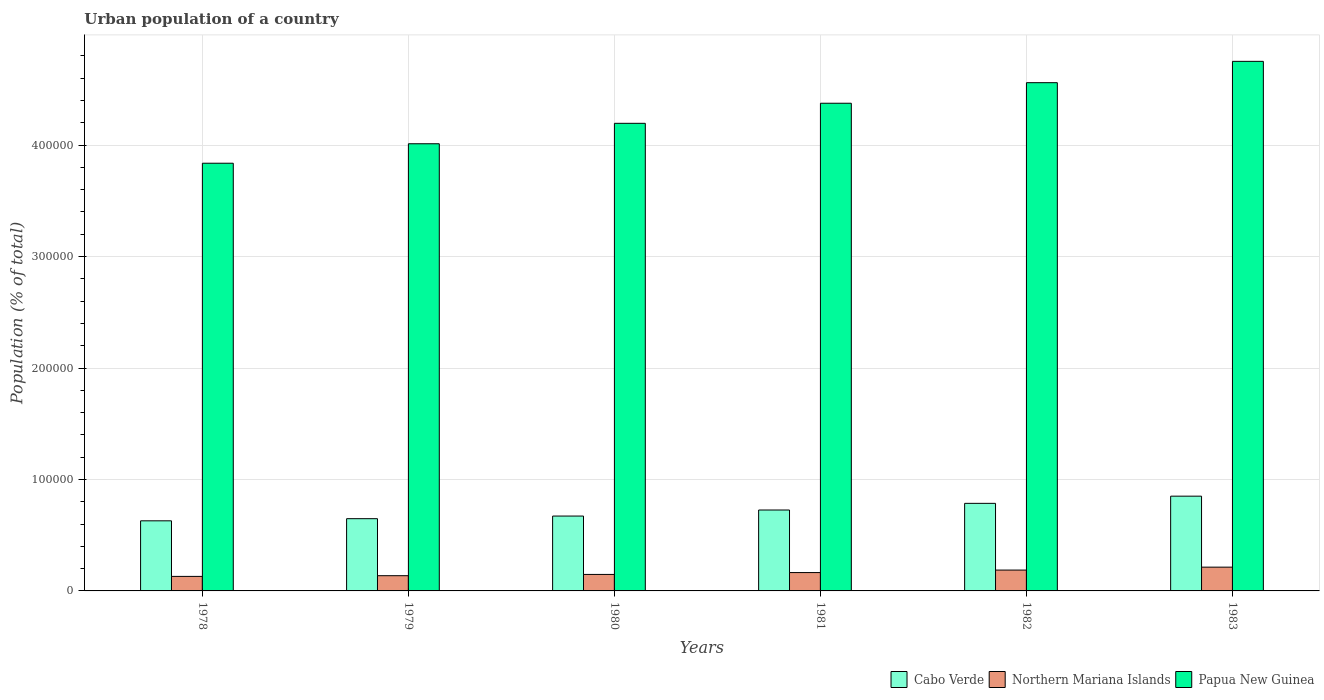How many groups of bars are there?
Ensure brevity in your answer.  6. Are the number of bars per tick equal to the number of legend labels?
Offer a very short reply. Yes. Are the number of bars on each tick of the X-axis equal?
Keep it short and to the point. Yes. How many bars are there on the 1st tick from the left?
Offer a very short reply. 3. How many bars are there on the 3rd tick from the right?
Provide a short and direct response. 3. What is the label of the 1st group of bars from the left?
Ensure brevity in your answer.  1978. What is the urban population in Northern Mariana Islands in 1981?
Ensure brevity in your answer.  1.65e+04. Across all years, what is the maximum urban population in Cabo Verde?
Make the answer very short. 8.50e+04. Across all years, what is the minimum urban population in Northern Mariana Islands?
Keep it short and to the point. 1.30e+04. In which year was the urban population in Cabo Verde minimum?
Make the answer very short. 1978. What is the total urban population in Papua New Guinea in the graph?
Your answer should be compact. 2.57e+06. What is the difference between the urban population in Cabo Verde in 1979 and that in 1982?
Give a very brief answer. -1.37e+04. What is the difference between the urban population in Cabo Verde in 1978 and the urban population in Papua New Guinea in 1980?
Your response must be concise. -3.57e+05. What is the average urban population in Northern Mariana Islands per year?
Offer a very short reply. 1.63e+04. In the year 1979, what is the difference between the urban population in Papua New Guinea and urban population in Cabo Verde?
Ensure brevity in your answer.  3.36e+05. In how many years, is the urban population in Cabo Verde greater than 240000 %?
Your response must be concise. 0. What is the ratio of the urban population in Cabo Verde in 1980 to that in 1982?
Your answer should be compact. 0.85. Is the urban population in Papua New Guinea in 1982 less than that in 1983?
Your answer should be compact. Yes. Is the difference between the urban population in Papua New Guinea in 1979 and 1982 greater than the difference between the urban population in Cabo Verde in 1979 and 1982?
Keep it short and to the point. No. What is the difference between the highest and the second highest urban population in Cabo Verde?
Offer a terse response. 6449. What is the difference between the highest and the lowest urban population in Northern Mariana Islands?
Give a very brief answer. 8305. Is the sum of the urban population in Cabo Verde in 1978 and 1981 greater than the maximum urban population in Papua New Guinea across all years?
Your answer should be very brief. No. What does the 2nd bar from the left in 1980 represents?
Offer a very short reply. Northern Mariana Islands. What does the 1st bar from the right in 1980 represents?
Your response must be concise. Papua New Guinea. Is it the case that in every year, the sum of the urban population in Papua New Guinea and urban population in Northern Mariana Islands is greater than the urban population in Cabo Verde?
Offer a very short reply. Yes. How many years are there in the graph?
Make the answer very short. 6. What is the difference between two consecutive major ticks on the Y-axis?
Give a very brief answer. 1.00e+05. Where does the legend appear in the graph?
Make the answer very short. Bottom right. What is the title of the graph?
Keep it short and to the point. Urban population of a country. Does "Belize" appear as one of the legend labels in the graph?
Give a very brief answer. No. What is the label or title of the Y-axis?
Offer a terse response. Population (% of total). What is the Population (% of total) in Cabo Verde in 1978?
Offer a terse response. 6.29e+04. What is the Population (% of total) of Northern Mariana Islands in 1978?
Your response must be concise. 1.30e+04. What is the Population (% of total) in Papua New Guinea in 1978?
Give a very brief answer. 3.84e+05. What is the Population (% of total) in Cabo Verde in 1979?
Provide a succinct answer. 6.48e+04. What is the Population (% of total) in Northern Mariana Islands in 1979?
Provide a short and direct response. 1.37e+04. What is the Population (% of total) of Papua New Guinea in 1979?
Keep it short and to the point. 4.01e+05. What is the Population (% of total) of Cabo Verde in 1980?
Provide a short and direct response. 6.72e+04. What is the Population (% of total) in Northern Mariana Islands in 1980?
Provide a short and direct response. 1.48e+04. What is the Population (% of total) of Papua New Guinea in 1980?
Make the answer very short. 4.20e+05. What is the Population (% of total) in Cabo Verde in 1981?
Your answer should be compact. 7.26e+04. What is the Population (% of total) of Northern Mariana Islands in 1981?
Your answer should be compact. 1.65e+04. What is the Population (% of total) of Papua New Guinea in 1981?
Keep it short and to the point. 4.38e+05. What is the Population (% of total) of Cabo Verde in 1982?
Ensure brevity in your answer.  7.86e+04. What is the Population (% of total) in Northern Mariana Islands in 1982?
Make the answer very short. 1.87e+04. What is the Population (% of total) in Papua New Guinea in 1982?
Offer a terse response. 4.56e+05. What is the Population (% of total) in Cabo Verde in 1983?
Your answer should be compact. 8.50e+04. What is the Population (% of total) of Northern Mariana Islands in 1983?
Offer a terse response. 2.13e+04. What is the Population (% of total) of Papua New Guinea in 1983?
Offer a terse response. 4.75e+05. Across all years, what is the maximum Population (% of total) of Cabo Verde?
Ensure brevity in your answer.  8.50e+04. Across all years, what is the maximum Population (% of total) of Northern Mariana Islands?
Offer a terse response. 2.13e+04. Across all years, what is the maximum Population (% of total) in Papua New Guinea?
Provide a succinct answer. 4.75e+05. Across all years, what is the minimum Population (% of total) of Cabo Verde?
Provide a short and direct response. 6.29e+04. Across all years, what is the minimum Population (% of total) in Northern Mariana Islands?
Provide a short and direct response. 1.30e+04. Across all years, what is the minimum Population (% of total) in Papua New Guinea?
Keep it short and to the point. 3.84e+05. What is the total Population (% of total) of Cabo Verde in the graph?
Give a very brief answer. 4.31e+05. What is the total Population (% of total) of Northern Mariana Islands in the graph?
Provide a short and direct response. 9.80e+04. What is the total Population (% of total) in Papua New Guinea in the graph?
Your response must be concise. 2.57e+06. What is the difference between the Population (% of total) of Cabo Verde in 1978 and that in 1979?
Your response must be concise. -1918. What is the difference between the Population (% of total) of Northern Mariana Islands in 1978 and that in 1979?
Keep it short and to the point. -627. What is the difference between the Population (% of total) in Papua New Guinea in 1978 and that in 1979?
Your response must be concise. -1.75e+04. What is the difference between the Population (% of total) of Cabo Verde in 1978 and that in 1980?
Make the answer very short. -4271. What is the difference between the Population (% of total) of Northern Mariana Islands in 1978 and that in 1980?
Provide a short and direct response. -1767. What is the difference between the Population (% of total) of Papua New Guinea in 1978 and that in 1980?
Your answer should be compact. -3.58e+04. What is the difference between the Population (% of total) of Cabo Verde in 1978 and that in 1981?
Keep it short and to the point. -9696. What is the difference between the Population (% of total) in Northern Mariana Islands in 1978 and that in 1981?
Provide a succinct answer. -3442. What is the difference between the Population (% of total) of Papua New Guinea in 1978 and that in 1981?
Offer a terse response. -5.38e+04. What is the difference between the Population (% of total) of Cabo Verde in 1978 and that in 1982?
Ensure brevity in your answer.  -1.57e+04. What is the difference between the Population (% of total) in Northern Mariana Islands in 1978 and that in 1982?
Your answer should be very brief. -5679. What is the difference between the Population (% of total) of Papua New Guinea in 1978 and that in 1982?
Your response must be concise. -7.23e+04. What is the difference between the Population (% of total) of Cabo Verde in 1978 and that in 1983?
Provide a short and direct response. -2.21e+04. What is the difference between the Population (% of total) in Northern Mariana Islands in 1978 and that in 1983?
Your answer should be very brief. -8305. What is the difference between the Population (% of total) of Papua New Guinea in 1978 and that in 1983?
Provide a succinct answer. -9.14e+04. What is the difference between the Population (% of total) of Cabo Verde in 1979 and that in 1980?
Your response must be concise. -2353. What is the difference between the Population (% of total) in Northern Mariana Islands in 1979 and that in 1980?
Your answer should be compact. -1140. What is the difference between the Population (% of total) in Papua New Guinea in 1979 and that in 1980?
Make the answer very short. -1.83e+04. What is the difference between the Population (% of total) in Cabo Verde in 1979 and that in 1981?
Ensure brevity in your answer.  -7778. What is the difference between the Population (% of total) in Northern Mariana Islands in 1979 and that in 1981?
Your response must be concise. -2815. What is the difference between the Population (% of total) of Papua New Guinea in 1979 and that in 1981?
Your response must be concise. -3.64e+04. What is the difference between the Population (% of total) in Cabo Verde in 1979 and that in 1982?
Offer a very short reply. -1.37e+04. What is the difference between the Population (% of total) of Northern Mariana Islands in 1979 and that in 1982?
Your answer should be very brief. -5052. What is the difference between the Population (% of total) of Papua New Guinea in 1979 and that in 1982?
Offer a very short reply. -5.48e+04. What is the difference between the Population (% of total) of Cabo Verde in 1979 and that in 1983?
Provide a succinct answer. -2.02e+04. What is the difference between the Population (% of total) of Northern Mariana Islands in 1979 and that in 1983?
Offer a very short reply. -7678. What is the difference between the Population (% of total) of Papua New Guinea in 1979 and that in 1983?
Provide a short and direct response. -7.39e+04. What is the difference between the Population (% of total) in Cabo Verde in 1980 and that in 1981?
Provide a succinct answer. -5425. What is the difference between the Population (% of total) in Northern Mariana Islands in 1980 and that in 1981?
Give a very brief answer. -1675. What is the difference between the Population (% of total) in Papua New Guinea in 1980 and that in 1981?
Make the answer very short. -1.80e+04. What is the difference between the Population (% of total) of Cabo Verde in 1980 and that in 1982?
Ensure brevity in your answer.  -1.14e+04. What is the difference between the Population (% of total) in Northern Mariana Islands in 1980 and that in 1982?
Your response must be concise. -3912. What is the difference between the Population (% of total) of Papua New Guinea in 1980 and that in 1982?
Provide a succinct answer. -3.65e+04. What is the difference between the Population (% of total) in Cabo Verde in 1980 and that in 1983?
Provide a succinct answer. -1.78e+04. What is the difference between the Population (% of total) of Northern Mariana Islands in 1980 and that in 1983?
Your answer should be compact. -6538. What is the difference between the Population (% of total) of Papua New Guinea in 1980 and that in 1983?
Your response must be concise. -5.56e+04. What is the difference between the Population (% of total) in Cabo Verde in 1981 and that in 1982?
Offer a terse response. -5970. What is the difference between the Population (% of total) of Northern Mariana Islands in 1981 and that in 1982?
Your answer should be compact. -2237. What is the difference between the Population (% of total) of Papua New Guinea in 1981 and that in 1982?
Make the answer very short. -1.84e+04. What is the difference between the Population (% of total) of Cabo Verde in 1981 and that in 1983?
Provide a succinct answer. -1.24e+04. What is the difference between the Population (% of total) of Northern Mariana Islands in 1981 and that in 1983?
Make the answer very short. -4863. What is the difference between the Population (% of total) in Papua New Guinea in 1981 and that in 1983?
Your answer should be very brief. -3.76e+04. What is the difference between the Population (% of total) of Cabo Verde in 1982 and that in 1983?
Your answer should be compact. -6449. What is the difference between the Population (% of total) in Northern Mariana Islands in 1982 and that in 1983?
Provide a short and direct response. -2626. What is the difference between the Population (% of total) of Papua New Guinea in 1982 and that in 1983?
Give a very brief answer. -1.91e+04. What is the difference between the Population (% of total) in Cabo Verde in 1978 and the Population (% of total) in Northern Mariana Islands in 1979?
Keep it short and to the point. 4.92e+04. What is the difference between the Population (% of total) of Cabo Verde in 1978 and the Population (% of total) of Papua New Guinea in 1979?
Provide a short and direct response. -3.38e+05. What is the difference between the Population (% of total) of Northern Mariana Islands in 1978 and the Population (% of total) of Papua New Guinea in 1979?
Offer a terse response. -3.88e+05. What is the difference between the Population (% of total) in Cabo Verde in 1978 and the Population (% of total) in Northern Mariana Islands in 1980?
Ensure brevity in your answer.  4.81e+04. What is the difference between the Population (% of total) in Cabo Verde in 1978 and the Population (% of total) in Papua New Guinea in 1980?
Your response must be concise. -3.57e+05. What is the difference between the Population (% of total) of Northern Mariana Islands in 1978 and the Population (% of total) of Papua New Guinea in 1980?
Your answer should be compact. -4.06e+05. What is the difference between the Population (% of total) in Cabo Verde in 1978 and the Population (% of total) in Northern Mariana Islands in 1981?
Your response must be concise. 4.64e+04. What is the difference between the Population (% of total) in Cabo Verde in 1978 and the Population (% of total) in Papua New Guinea in 1981?
Offer a very short reply. -3.75e+05. What is the difference between the Population (% of total) in Northern Mariana Islands in 1978 and the Population (% of total) in Papua New Guinea in 1981?
Your answer should be very brief. -4.25e+05. What is the difference between the Population (% of total) of Cabo Verde in 1978 and the Population (% of total) of Northern Mariana Islands in 1982?
Provide a short and direct response. 4.42e+04. What is the difference between the Population (% of total) of Cabo Verde in 1978 and the Population (% of total) of Papua New Guinea in 1982?
Give a very brief answer. -3.93e+05. What is the difference between the Population (% of total) of Northern Mariana Islands in 1978 and the Population (% of total) of Papua New Guinea in 1982?
Offer a very short reply. -4.43e+05. What is the difference between the Population (% of total) of Cabo Verde in 1978 and the Population (% of total) of Northern Mariana Islands in 1983?
Your response must be concise. 4.16e+04. What is the difference between the Population (% of total) of Cabo Verde in 1978 and the Population (% of total) of Papua New Guinea in 1983?
Offer a terse response. -4.12e+05. What is the difference between the Population (% of total) of Northern Mariana Islands in 1978 and the Population (% of total) of Papua New Guinea in 1983?
Ensure brevity in your answer.  -4.62e+05. What is the difference between the Population (% of total) in Cabo Verde in 1979 and the Population (% of total) in Northern Mariana Islands in 1980?
Ensure brevity in your answer.  5.00e+04. What is the difference between the Population (% of total) of Cabo Verde in 1979 and the Population (% of total) of Papua New Guinea in 1980?
Make the answer very short. -3.55e+05. What is the difference between the Population (% of total) of Northern Mariana Islands in 1979 and the Population (% of total) of Papua New Guinea in 1980?
Ensure brevity in your answer.  -4.06e+05. What is the difference between the Population (% of total) of Cabo Verde in 1979 and the Population (% of total) of Northern Mariana Islands in 1981?
Provide a short and direct response. 4.83e+04. What is the difference between the Population (% of total) in Cabo Verde in 1979 and the Population (% of total) in Papua New Guinea in 1981?
Your answer should be very brief. -3.73e+05. What is the difference between the Population (% of total) in Northern Mariana Islands in 1979 and the Population (% of total) in Papua New Guinea in 1981?
Your answer should be very brief. -4.24e+05. What is the difference between the Population (% of total) of Cabo Verde in 1979 and the Population (% of total) of Northern Mariana Islands in 1982?
Make the answer very short. 4.61e+04. What is the difference between the Population (% of total) in Cabo Verde in 1979 and the Population (% of total) in Papua New Guinea in 1982?
Offer a terse response. -3.91e+05. What is the difference between the Population (% of total) of Northern Mariana Islands in 1979 and the Population (% of total) of Papua New Guinea in 1982?
Provide a short and direct response. -4.42e+05. What is the difference between the Population (% of total) in Cabo Verde in 1979 and the Population (% of total) in Northern Mariana Islands in 1983?
Provide a succinct answer. 4.35e+04. What is the difference between the Population (% of total) in Cabo Verde in 1979 and the Population (% of total) in Papua New Guinea in 1983?
Your answer should be very brief. -4.10e+05. What is the difference between the Population (% of total) in Northern Mariana Islands in 1979 and the Population (% of total) in Papua New Guinea in 1983?
Your response must be concise. -4.61e+05. What is the difference between the Population (% of total) in Cabo Verde in 1980 and the Population (% of total) in Northern Mariana Islands in 1981?
Your response must be concise. 5.07e+04. What is the difference between the Population (% of total) in Cabo Verde in 1980 and the Population (% of total) in Papua New Guinea in 1981?
Provide a succinct answer. -3.70e+05. What is the difference between the Population (% of total) of Northern Mariana Islands in 1980 and the Population (% of total) of Papua New Guinea in 1981?
Your response must be concise. -4.23e+05. What is the difference between the Population (% of total) in Cabo Verde in 1980 and the Population (% of total) in Northern Mariana Islands in 1982?
Ensure brevity in your answer.  4.85e+04. What is the difference between the Population (% of total) in Cabo Verde in 1980 and the Population (% of total) in Papua New Guinea in 1982?
Ensure brevity in your answer.  -3.89e+05. What is the difference between the Population (% of total) of Northern Mariana Islands in 1980 and the Population (% of total) of Papua New Guinea in 1982?
Your response must be concise. -4.41e+05. What is the difference between the Population (% of total) in Cabo Verde in 1980 and the Population (% of total) in Northern Mariana Islands in 1983?
Provide a succinct answer. 4.58e+04. What is the difference between the Population (% of total) in Cabo Verde in 1980 and the Population (% of total) in Papua New Guinea in 1983?
Your response must be concise. -4.08e+05. What is the difference between the Population (% of total) of Northern Mariana Islands in 1980 and the Population (% of total) of Papua New Guinea in 1983?
Provide a short and direct response. -4.60e+05. What is the difference between the Population (% of total) in Cabo Verde in 1981 and the Population (% of total) in Northern Mariana Islands in 1982?
Provide a short and direct response. 5.39e+04. What is the difference between the Population (% of total) of Cabo Verde in 1981 and the Population (% of total) of Papua New Guinea in 1982?
Provide a short and direct response. -3.83e+05. What is the difference between the Population (% of total) in Northern Mariana Islands in 1981 and the Population (% of total) in Papua New Guinea in 1982?
Offer a terse response. -4.40e+05. What is the difference between the Population (% of total) in Cabo Verde in 1981 and the Population (% of total) in Northern Mariana Islands in 1983?
Give a very brief answer. 5.13e+04. What is the difference between the Population (% of total) in Cabo Verde in 1981 and the Population (% of total) in Papua New Guinea in 1983?
Your answer should be very brief. -4.03e+05. What is the difference between the Population (% of total) in Northern Mariana Islands in 1981 and the Population (% of total) in Papua New Guinea in 1983?
Your answer should be compact. -4.59e+05. What is the difference between the Population (% of total) of Cabo Verde in 1982 and the Population (% of total) of Northern Mariana Islands in 1983?
Your response must be concise. 5.72e+04. What is the difference between the Population (% of total) of Cabo Verde in 1982 and the Population (% of total) of Papua New Guinea in 1983?
Keep it short and to the point. -3.97e+05. What is the difference between the Population (% of total) in Northern Mariana Islands in 1982 and the Population (% of total) in Papua New Guinea in 1983?
Give a very brief answer. -4.56e+05. What is the average Population (% of total) in Cabo Verde per year?
Your answer should be compact. 7.18e+04. What is the average Population (% of total) in Northern Mariana Islands per year?
Your answer should be very brief. 1.63e+04. What is the average Population (% of total) of Papua New Guinea per year?
Ensure brevity in your answer.  4.29e+05. In the year 1978, what is the difference between the Population (% of total) of Cabo Verde and Population (% of total) of Northern Mariana Islands?
Offer a very short reply. 4.99e+04. In the year 1978, what is the difference between the Population (% of total) in Cabo Verde and Population (% of total) in Papua New Guinea?
Offer a terse response. -3.21e+05. In the year 1978, what is the difference between the Population (% of total) of Northern Mariana Islands and Population (% of total) of Papua New Guinea?
Your response must be concise. -3.71e+05. In the year 1979, what is the difference between the Population (% of total) in Cabo Verde and Population (% of total) in Northern Mariana Islands?
Keep it short and to the point. 5.12e+04. In the year 1979, what is the difference between the Population (% of total) in Cabo Verde and Population (% of total) in Papua New Guinea?
Keep it short and to the point. -3.36e+05. In the year 1979, what is the difference between the Population (% of total) of Northern Mariana Islands and Population (% of total) of Papua New Guinea?
Your answer should be compact. -3.88e+05. In the year 1980, what is the difference between the Population (% of total) of Cabo Verde and Population (% of total) of Northern Mariana Islands?
Keep it short and to the point. 5.24e+04. In the year 1980, what is the difference between the Population (% of total) in Cabo Verde and Population (% of total) in Papua New Guinea?
Your answer should be compact. -3.52e+05. In the year 1980, what is the difference between the Population (% of total) in Northern Mariana Islands and Population (% of total) in Papua New Guinea?
Your answer should be very brief. -4.05e+05. In the year 1981, what is the difference between the Population (% of total) of Cabo Verde and Population (% of total) of Northern Mariana Islands?
Ensure brevity in your answer.  5.61e+04. In the year 1981, what is the difference between the Population (% of total) of Cabo Verde and Population (% of total) of Papua New Guinea?
Give a very brief answer. -3.65e+05. In the year 1981, what is the difference between the Population (% of total) of Northern Mariana Islands and Population (% of total) of Papua New Guinea?
Offer a very short reply. -4.21e+05. In the year 1982, what is the difference between the Population (% of total) in Cabo Verde and Population (% of total) in Northern Mariana Islands?
Give a very brief answer. 5.99e+04. In the year 1982, what is the difference between the Population (% of total) of Cabo Verde and Population (% of total) of Papua New Guinea?
Offer a very short reply. -3.77e+05. In the year 1982, what is the difference between the Population (% of total) in Northern Mariana Islands and Population (% of total) in Papua New Guinea?
Make the answer very short. -4.37e+05. In the year 1983, what is the difference between the Population (% of total) in Cabo Verde and Population (% of total) in Northern Mariana Islands?
Ensure brevity in your answer.  6.37e+04. In the year 1983, what is the difference between the Population (% of total) of Cabo Verde and Population (% of total) of Papua New Guinea?
Your response must be concise. -3.90e+05. In the year 1983, what is the difference between the Population (% of total) of Northern Mariana Islands and Population (% of total) of Papua New Guinea?
Ensure brevity in your answer.  -4.54e+05. What is the ratio of the Population (% of total) of Cabo Verde in 1978 to that in 1979?
Your answer should be very brief. 0.97. What is the ratio of the Population (% of total) in Northern Mariana Islands in 1978 to that in 1979?
Offer a very short reply. 0.95. What is the ratio of the Population (% of total) in Papua New Guinea in 1978 to that in 1979?
Your answer should be very brief. 0.96. What is the ratio of the Population (% of total) in Cabo Verde in 1978 to that in 1980?
Give a very brief answer. 0.94. What is the ratio of the Population (% of total) of Northern Mariana Islands in 1978 to that in 1980?
Your answer should be compact. 0.88. What is the ratio of the Population (% of total) of Papua New Guinea in 1978 to that in 1980?
Provide a short and direct response. 0.91. What is the ratio of the Population (% of total) in Cabo Verde in 1978 to that in 1981?
Your response must be concise. 0.87. What is the ratio of the Population (% of total) in Northern Mariana Islands in 1978 to that in 1981?
Keep it short and to the point. 0.79. What is the ratio of the Population (% of total) in Papua New Guinea in 1978 to that in 1981?
Provide a short and direct response. 0.88. What is the ratio of the Population (% of total) of Cabo Verde in 1978 to that in 1982?
Offer a terse response. 0.8. What is the ratio of the Population (% of total) of Northern Mariana Islands in 1978 to that in 1982?
Give a very brief answer. 0.7. What is the ratio of the Population (% of total) of Papua New Guinea in 1978 to that in 1982?
Provide a short and direct response. 0.84. What is the ratio of the Population (% of total) of Cabo Verde in 1978 to that in 1983?
Offer a very short reply. 0.74. What is the ratio of the Population (% of total) of Northern Mariana Islands in 1978 to that in 1983?
Ensure brevity in your answer.  0.61. What is the ratio of the Population (% of total) of Papua New Guinea in 1978 to that in 1983?
Keep it short and to the point. 0.81. What is the ratio of the Population (% of total) of Northern Mariana Islands in 1979 to that in 1980?
Your answer should be very brief. 0.92. What is the ratio of the Population (% of total) in Papua New Guinea in 1979 to that in 1980?
Provide a succinct answer. 0.96. What is the ratio of the Population (% of total) of Cabo Verde in 1979 to that in 1981?
Your answer should be compact. 0.89. What is the ratio of the Population (% of total) of Northern Mariana Islands in 1979 to that in 1981?
Provide a short and direct response. 0.83. What is the ratio of the Population (% of total) of Papua New Guinea in 1979 to that in 1981?
Ensure brevity in your answer.  0.92. What is the ratio of the Population (% of total) of Cabo Verde in 1979 to that in 1982?
Provide a short and direct response. 0.82. What is the ratio of the Population (% of total) in Northern Mariana Islands in 1979 to that in 1982?
Make the answer very short. 0.73. What is the ratio of the Population (% of total) in Papua New Guinea in 1979 to that in 1982?
Ensure brevity in your answer.  0.88. What is the ratio of the Population (% of total) of Cabo Verde in 1979 to that in 1983?
Make the answer very short. 0.76. What is the ratio of the Population (% of total) in Northern Mariana Islands in 1979 to that in 1983?
Make the answer very short. 0.64. What is the ratio of the Population (% of total) in Papua New Guinea in 1979 to that in 1983?
Your answer should be compact. 0.84. What is the ratio of the Population (% of total) of Cabo Verde in 1980 to that in 1981?
Make the answer very short. 0.93. What is the ratio of the Population (% of total) of Northern Mariana Islands in 1980 to that in 1981?
Offer a terse response. 0.9. What is the ratio of the Population (% of total) in Papua New Guinea in 1980 to that in 1981?
Give a very brief answer. 0.96. What is the ratio of the Population (% of total) of Cabo Verde in 1980 to that in 1982?
Ensure brevity in your answer.  0.85. What is the ratio of the Population (% of total) of Northern Mariana Islands in 1980 to that in 1982?
Provide a succinct answer. 0.79. What is the ratio of the Population (% of total) of Cabo Verde in 1980 to that in 1983?
Ensure brevity in your answer.  0.79. What is the ratio of the Population (% of total) of Northern Mariana Islands in 1980 to that in 1983?
Make the answer very short. 0.69. What is the ratio of the Population (% of total) of Papua New Guinea in 1980 to that in 1983?
Give a very brief answer. 0.88. What is the ratio of the Population (% of total) of Cabo Verde in 1981 to that in 1982?
Provide a short and direct response. 0.92. What is the ratio of the Population (% of total) in Northern Mariana Islands in 1981 to that in 1982?
Make the answer very short. 0.88. What is the ratio of the Population (% of total) of Papua New Guinea in 1981 to that in 1982?
Provide a short and direct response. 0.96. What is the ratio of the Population (% of total) in Cabo Verde in 1981 to that in 1983?
Make the answer very short. 0.85. What is the ratio of the Population (% of total) of Northern Mariana Islands in 1981 to that in 1983?
Offer a very short reply. 0.77. What is the ratio of the Population (% of total) in Papua New Guinea in 1981 to that in 1983?
Give a very brief answer. 0.92. What is the ratio of the Population (% of total) of Cabo Verde in 1982 to that in 1983?
Ensure brevity in your answer.  0.92. What is the ratio of the Population (% of total) of Northern Mariana Islands in 1982 to that in 1983?
Provide a short and direct response. 0.88. What is the ratio of the Population (% of total) of Papua New Guinea in 1982 to that in 1983?
Give a very brief answer. 0.96. What is the difference between the highest and the second highest Population (% of total) of Cabo Verde?
Your answer should be compact. 6449. What is the difference between the highest and the second highest Population (% of total) in Northern Mariana Islands?
Provide a short and direct response. 2626. What is the difference between the highest and the second highest Population (% of total) of Papua New Guinea?
Make the answer very short. 1.91e+04. What is the difference between the highest and the lowest Population (% of total) in Cabo Verde?
Ensure brevity in your answer.  2.21e+04. What is the difference between the highest and the lowest Population (% of total) of Northern Mariana Islands?
Give a very brief answer. 8305. What is the difference between the highest and the lowest Population (% of total) of Papua New Guinea?
Make the answer very short. 9.14e+04. 